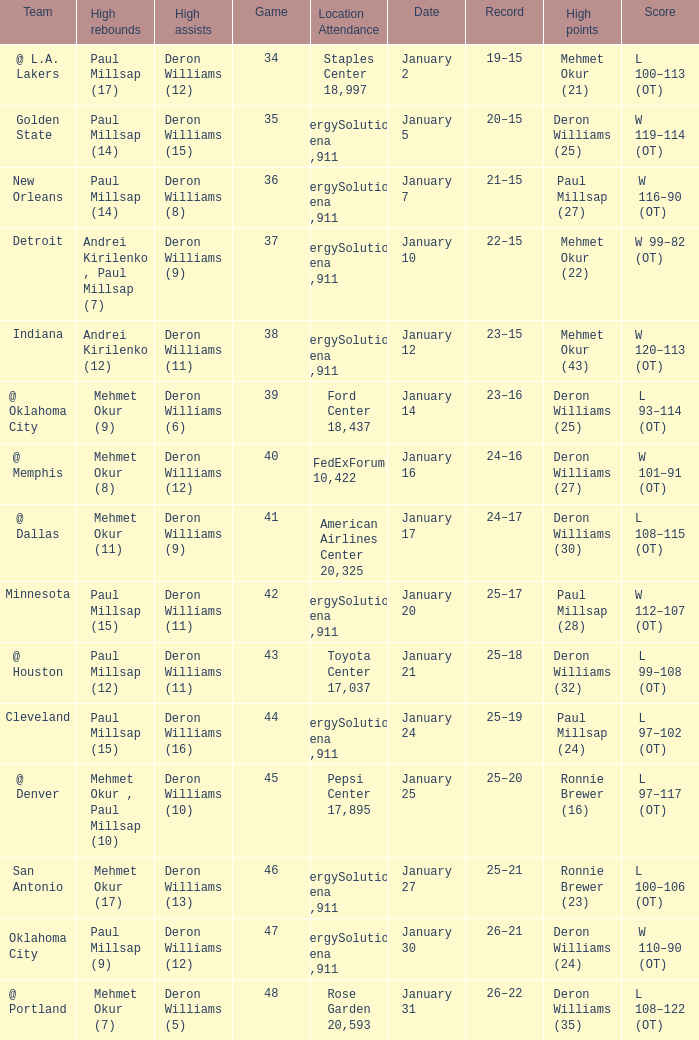Can you give me this table as a dict? {'header': ['Team', 'High rebounds', 'High assists', 'Game', 'Location Attendance', 'Date', 'Record', 'High points', 'Score'], 'rows': [['@ L.A. Lakers', 'Paul Millsap (17)', 'Deron Williams (12)', '34', 'Staples Center 18,997', 'January 2', '19–15', 'Mehmet Okur (21)', 'L 100–113 (OT)'], ['Golden State', 'Paul Millsap (14)', 'Deron Williams (15)', '35', 'EnergySolutions Arena 19,911', 'January 5', '20–15', 'Deron Williams (25)', 'W 119–114 (OT)'], ['New Orleans', 'Paul Millsap (14)', 'Deron Williams (8)', '36', 'EnergySolutions Arena 19,911', 'January 7', '21–15', 'Paul Millsap (27)', 'W 116–90 (OT)'], ['Detroit', 'Andrei Kirilenko , Paul Millsap (7)', 'Deron Williams (9)', '37', 'EnergySolutions Arena 19,911', 'January 10', '22–15', 'Mehmet Okur (22)', 'W 99–82 (OT)'], ['Indiana', 'Andrei Kirilenko (12)', 'Deron Williams (11)', '38', 'EnergySolutions Arena 19,911', 'January 12', '23–15', 'Mehmet Okur (43)', 'W 120–113 (OT)'], ['@ Oklahoma City', 'Mehmet Okur (9)', 'Deron Williams (6)', '39', 'Ford Center 18,437', 'January 14', '23–16', 'Deron Williams (25)', 'L 93–114 (OT)'], ['@ Memphis', 'Mehmet Okur (8)', 'Deron Williams (12)', '40', 'FedExForum 10,422', 'January 16', '24–16', 'Deron Williams (27)', 'W 101–91 (OT)'], ['@ Dallas', 'Mehmet Okur (11)', 'Deron Williams (9)', '41', 'American Airlines Center 20,325', 'January 17', '24–17', 'Deron Williams (30)', 'L 108–115 (OT)'], ['Minnesota', 'Paul Millsap (15)', 'Deron Williams (11)', '42', 'EnergySolutions Arena 19,911', 'January 20', '25–17', 'Paul Millsap (28)', 'W 112–107 (OT)'], ['@ Houston', 'Paul Millsap (12)', 'Deron Williams (11)', '43', 'Toyota Center 17,037', 'January 21', '25–18', 'Deron Williams (32)', 'L 99–108 (OT)'], ['Cleveland', 'Paul Millsap (15)', 'Deron Williams (16)', '44', 'EnergySolutions Arena 19,911', 'January 24', '25–19', 'Paul Millsap (24)', 'L 97–102 (OT)'], ['@ Denver', 'Mehmet Okur , Paul Millsap (10)', 'Deron Williams (10)', '45', 'Pepsi Center 17,895', 'January 25', '25–20', 'Ronnie Brewer (16)', 'L 97–117 (OT)'], ['San Antonio', 'Mehmet Okur (17)', 'Deron Williams (13)', '46', 'EnergySolutions Arena 19,911', 'January 27', '25–21', 'Ronnie Brewer (23)', 'L 100–106 (OT)'], ['Oklahoma City', 'Paul Millsap (9)', 'Deron Williams (12)', '47', 'EnergySolutions Arena 19,911', 'January 30', '26–21', 'Deron Williams (24)', 'W 110–90 (OT)'], ['@ Portland', 'Mehmet Okur (7)', 'Deron Williams (5)', '48', 'Rose Garden 20,593', 'January 31', '26–22', 'Deron Williams (35)', 'L 108–122 (OT)']]} What was the score of Game 48? L 108–122 (OT). 